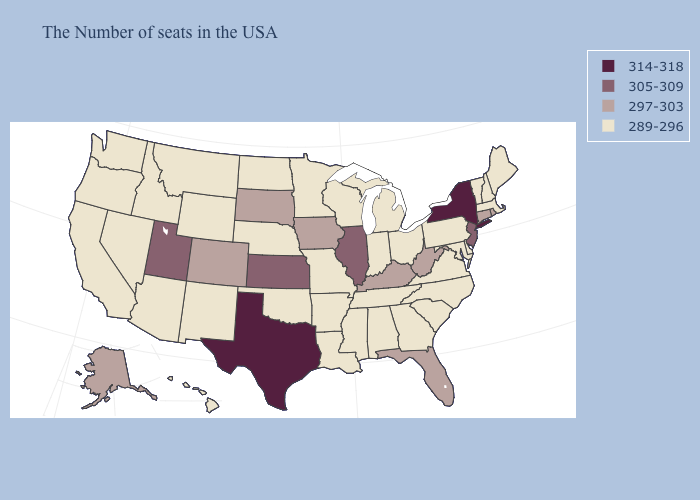Does Utah have a higher value than New Jersey?
Keep it brief. No. Name the states that have a value in the range 297-303?
Keep it brief. Rhode Island, Connecticut, West Virginia, Florida, Kentucky, Iowa, South Dakota, Colorado, Alaska. Does Connecticut have the lowest value in the USA?
Write a very short answer. No. Does the map have missing data?
Short answer required. No. What is the highest value in the Northeast ?
Write a very short answer. 314-318. Is the legend a continuous bar?
Keep it brief. No. Does Alaska have the same value as Florida?
Write a very short answer. Yes. Does Montana have a lower value than Alaska?
Write a very short answer. Yes. Among the states that border Louisiana , does Mississippi have the lowest value?
Concise answer only. Yes. What is the lowest value in the West?
Write a very short answer. 289-296. Does Texas have the highest value in the USA?
Quick response, please. Yes. What is the value of New Hampshire?
Short answer required. 289-296. Name the states that have a value in the range 305-309?
Be succinct. New Jersey, Illinois, Kansas, Utah. Name the states that have a value in the range 314-318?
Quick response, please. New York, Texas. What is the lowest value in states that border Colorado?
Short answer required. 289-296. 